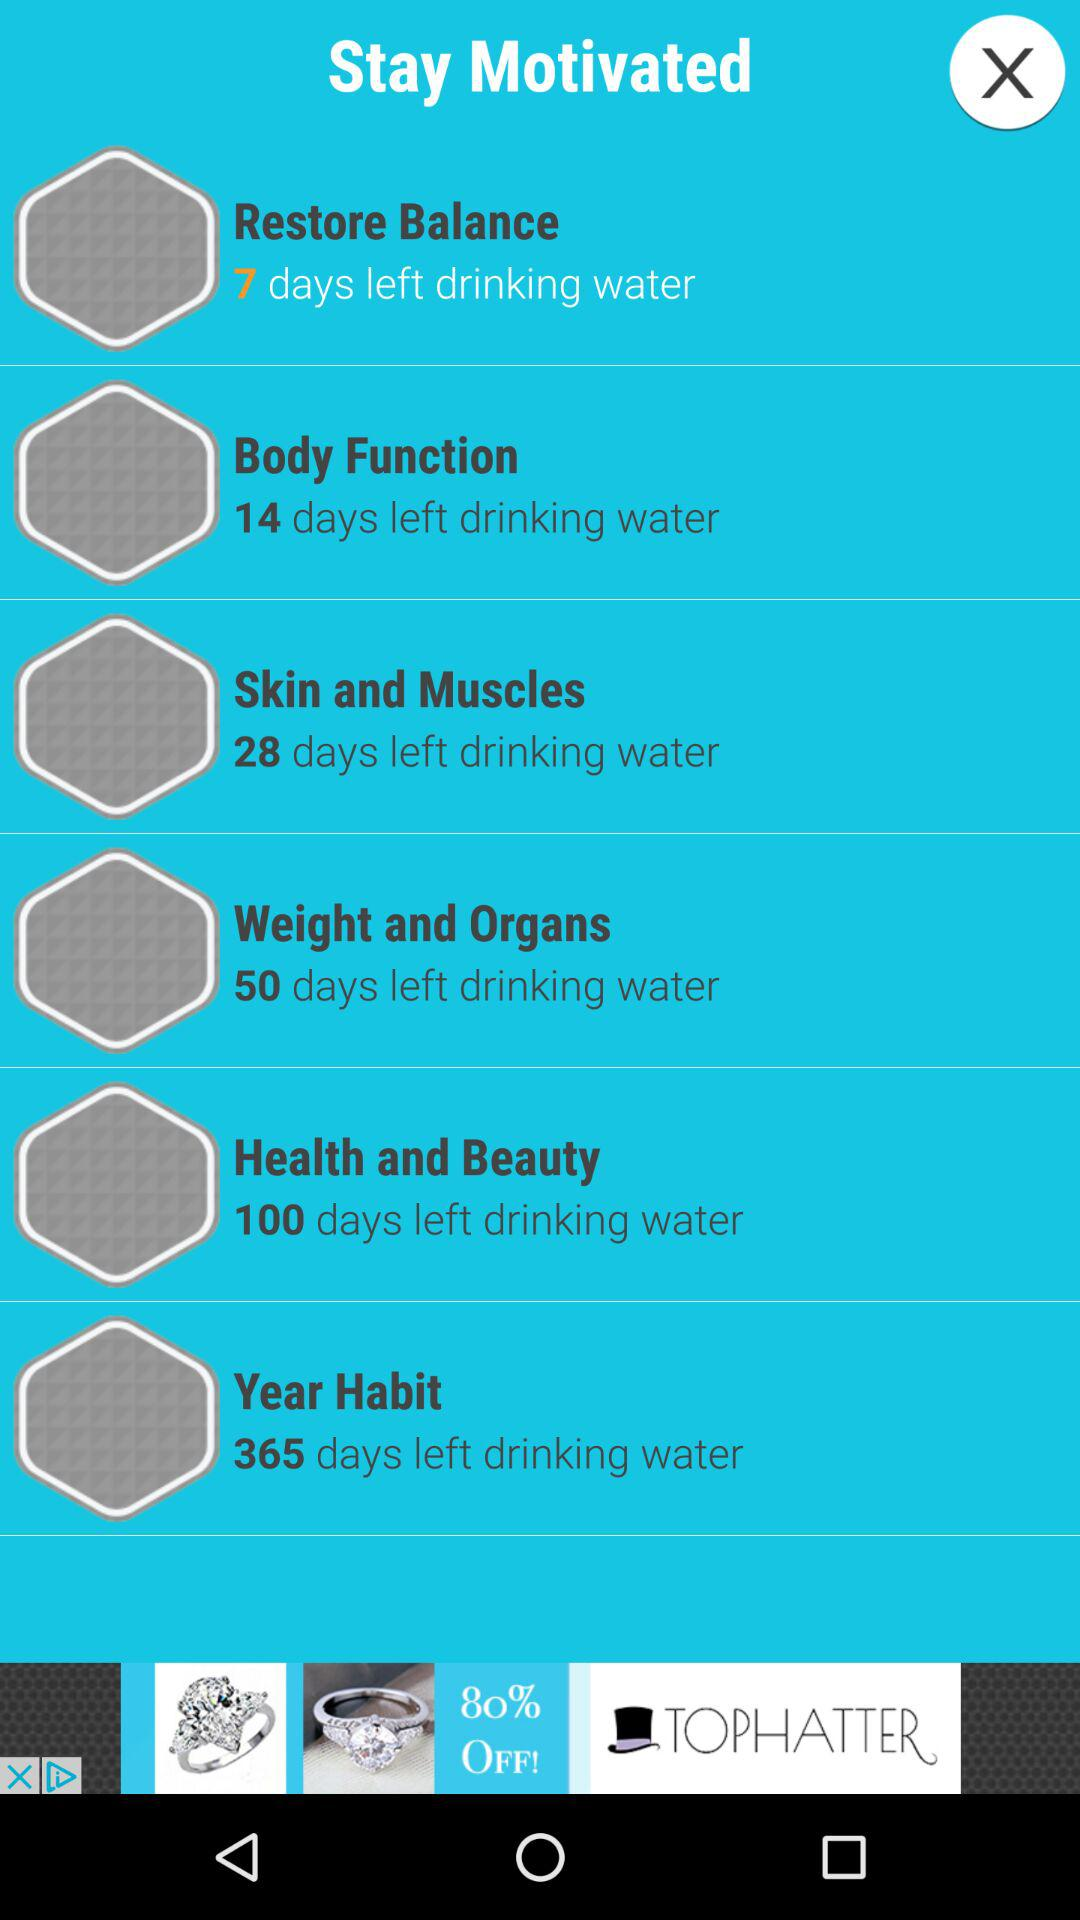How many days are left for drinking water in order to achieve "Restore Balance"? In order to achieve "Restore Balance", 7 days are left for drinking water. 